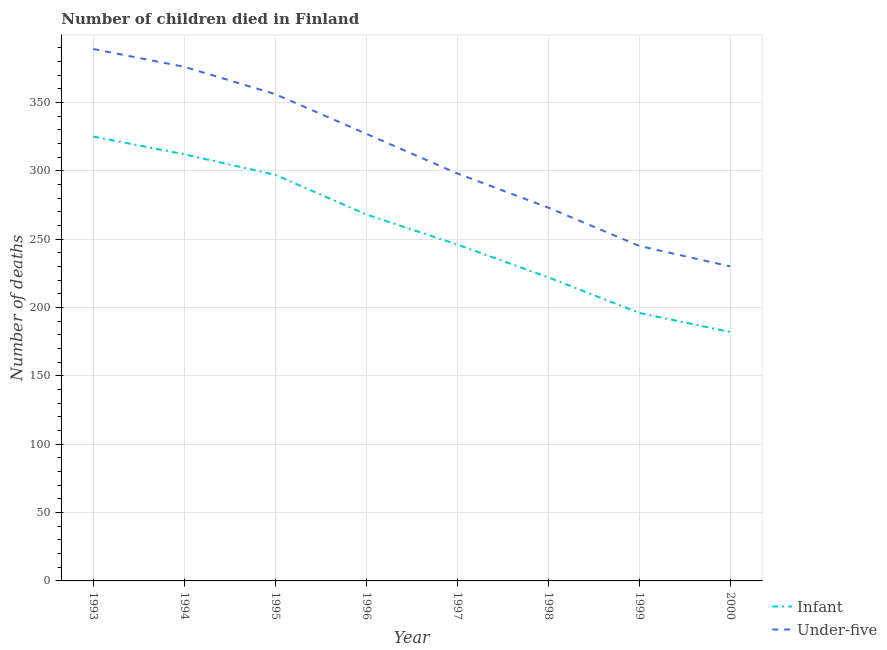What is the number of under-five deaths in 1998?
Offer a terse response. 273. Across all years, what is the maximum number of under-five deaths?
Offer a very short reply. 389. Across all years, what is the minimum number of under-five deaths?
Keep it short and to the point. 230. What is the total number of under-five deaths in the graph?
Keep it short and to the point. 2494. What is the difference between the number of under-five deaths in 1997 and that in 2000?
Keep it short and to the point. 68. What is the difference between the number of under-five deaths in 1998 and the number of infant deaths in 1996?
Your answer should be compact. 5. What is the average number of infant deaths per year?
Ensure brevity in your answer.  256. In the year 1993, what is the difference between the number of infant deaths and number of under-five deaths?
Provide a short and direct response. -64. What is the ratio of the number of infant deaths in 1993 to that in 2000?
Provide a short and direct response. 1.79. Is the number of under-five deaths in 1997 less than that in 1999?
Provide a short and direct response. No. What is the difference between the highest and the second highest number of under-five deaths?
Your answer should be compact. 13. What is the difference between the highest and the lowest number of under-five deaths?
Ensure brevity in your answer.  159. In how many years, is the number of under-five deaths greater than the average number of under-five deaths taken over all years?
Your response must be concise. 4. Is the number of infant deaths strictly less than the number of under-five deaths over the years?
Keep it short and to the point. Yes. How many years are there in the graph?
Your answer should be compact. 8. What is the difference between two consecutive major ticks on the Y-axis?
Keep it short and to the point. 50. Does the graph contain grids?
Provide a succinct answer. Yes. Where does the legend appear in the graph?
Your answer should be compact. Bottom right. What is the title of the graph?
Offer a terse response. Number of children died in Finland. What is the label or title of the Y-axis?
Provide a short and direct response. Number of deaths. What is the Number of deaths of Infant in 1993?
Keep it short and to the point. 325. What is the Number of deaths in Under-five in 1993?
Offer a terse response. 389. What is the Number of deaths in Infant in 1994?
Your answer should be very brief. 312. What is the Number of deaths of Under-five in 1994?
Keep it short and to the point. 376. What is the Number of deaths in Infant in 1995?
Your response must be concise. 297. What is the Number of deaths in Under-five in 1995?
Ensure brevity in your answer.  356. What is the Number of deaths of Infant in 1996?
Ensure brevity in your answer.  268. What is the Number of deaths of Under-five in 1996?
Your answer should be compact. 327. What is the Number of deaths in Infant in 1997?
Give a very brief answer. 246. What is the Number of deaths of Under-five in 1997?
Your answer should be compact. 298. What is the Number of deaths in Infant in 1998?
Provide a succinct answer. 222. What is the Number of deaths in Under-five in 1998?
Your answer should be very brief. 273. What is the Number of deaths of Infant in 1999?
Your answer should be compact. 196. What is the Number of deaths of Under-five in 1999?
Your answer should be very brief. 245. What is the Number of deaths in Infant in 2000?
Keep it short and to the point. 182. What is the Number of deaths of Under-five in 2000?
Your response must be concise. 230. Across all years, what is the maximum Number of deaths of Infant?
Provide a succinct answer. 325. Across all years, what is the maximum Number of deaths of Under-five?
Offer a terse response. 389. Across all years, what is the minimum Number of deaths of Infant?
Your response must be concise. 182. Across all years, what is the minimum Number of deaths in Under-five?
Give a very brief answer. 230. What is the total Number of deaths of Infant in the graph?
Ensure brevity in your answer.  2048. What is the total Number of deaths of Under-five in the graph?
Ensure brevity in your answer.  2494. What is the difference between the Number of deaths of Under-five in 1993 and that in 1994?
Your answer should be very brief. 13. What is the difference between the Number of deaths of Infant in 1993 and that in 1996?
Your response must be concise. 57. What is the difference between the Number of deaths of Under-five in 1993 and that in 1996?
Ensure brevity in your answer.  62. What is the difference between the Number of deaths of Infant in 1993 and that in 1997?
Offer a very short reply. 79. What is the difference between the Number of deaths in Under-five in 1993 and that in 1997?
Provide a succinct answer. 91. What is the difference between the Number of deaths of Infant in 1993 and that in 1998?
Provide a short and direct response. 103. What is the difference between the Number of deaths of Under-five in 1993 and that in 1998?
Make the answer very short. 116. What is the difference between the Number of deaths in Infant in 1993 and that in 1999?
Ensure brevity in your answer.  129. What is the difference between the Number of deaths in Under-five in 1993 and that in 1999?
Make the answer very short. 144. What is the difference between the Number of deaths of Infant in 1993 and that in 2000?
Provide a short and direct response. 143. What is the difference between the Number of deaths of Under-five in 1993 and that in 2000?
Your answer should be compact. 159. What is the difference between the Number of deaths of Infant in 1994 and that in 1995?
Keep it short and to the point. 15. What is the difference between the Number of deaths of Infant in 1994 and that in 1996?
Give a very brief answer. 44. What is the difference between the Number of deaths of Under-five in 1994 and that in 1996?
Offer a terse response. 49. What is the difference between the Number of deaths in Infant in 1994 and that in 1998?
Your response must be concise. 90. What is the difference between the Number of deaths in Under-five in 1994 and that in 1998?
Provide a short and direct response. 103. What is the difference between the Number of deaths in Infant in 1994 and that in 1999?
Keep it short and to the point. 116. What is the difference between the Number of deaths of Under-five in 1994 and that in 1999?
Make the answer very short. 131. What is the difference between the Number of deaths of Infant in 1994 and that in 2000?
Offer a terse response. 130. What is the difference between the Number of deaths of Under-five in 1994 and that in 2000?
Keep it short and to the point. 146. What is the difference between the Number of deaths in Infant in 1995 and that in 1997?
Keep it short and to the point. 51. What is the difference between the Number of deaths of Infant in 1995 and that in 1998?
Offer a terse response. 75. What is the difference between the Number of deaths of Infant in 1995 and that in 1999?
Ensure brevity in your answer.  101. What is the difference between the Number of deaths in Under-five in 1995 and that in 1999?
Provide a succinct answer. 111. What is the difference between the Number of deaths of Infant in 1995 and that in 2000?
Give a very brief answer. 115. What is the difference between the Number of deaths of Under-five in 1995 and that in 2000?
Ensure brevity in your answer.  126. What is the difference between the Number of deaths of Infant in 1996 and that in 1997?
Ensure brevity in your answer.  22. What is the difference between the Number of deaths of Under-five in 1996 and that in 1997?
Make the answer very short. 29. What is the difference between the Number of deaths of Infant in 1996 and that in 1998?
Give a very brief answer. 46. What is the difference between the Number of deaths in Infant in 1996 and that in 1999?
Offer a terse response. 72. What is the difference between the Number of deaths in Under-five in 1996 and that in 1999?
Ensure brevity in your answer.  82. What is the difference between the Number of deaths in Under-five in 1996 and that in 2000?
Your response must be concise. 97. What is the difference between the Number of deaths in Under-five in 1997 and that in 1999?
Offer a very short reply. 53. What is the difference between the Number of deaths of Under-five in 1997 and that in 2000?
Your response must be concise. 68. What is the difference between the Number of deaths in Infant in 1998 and that in 1999?
Give a very brief answer. 26. What is the difference between the Number of deaths in Under-five in 1998 and that in 1999?
Your response must be concise. 28. What is the difference between the Number of deaths in Under-five in 1998 and that in 2000?
Your response must be concise. 43. What is the difference between the Number of deaths of Infant in 1993 and the Number of deaths of Under-five in 1994?
Offer a terse response. -51. What is the difference between the Number of deaths of Infant in 1993 and the Number of deaths of Under-five in 1995?
Your answer should be compact. -31. What is the difference between the Number of deaths in Infant in 1993 and the Number of deaths in Under-five in 1996?
Provide a succinct answer. -2. What is the difference between the Number of deaths of Infant in 1993 and the Number of deaths of Under-five in 1997?
Your answer should be compact. 27. What is the difference between the Number of deaths in Infant in 1993 and the Number of deaths in Under-five in 2000?
Ensure brevity in your answer.  95. What is the difference between the Number of deaths of Infant in 1994 and the Number of deaths of Under-five in 1995?
Make the answer very short. -44. What is the difference between the Number of deaths in Infant in 1994 and the Number of deaths in Under-five in 1996?
Give a very brief answer. -15. What is the difference between the Number of deaths in Infant in 1994 and the Number of deaths in Under-five in 1998?
Offer a very short reply. 39. What is the difference between the Number of deaths in Infant in 1995 and the Number of deaths in Under-five in 1996?
Your response must be concise. -30. What is the difference between the Number of deaths in Infant in 1995 and the Number of deaths in Under-five in 2000?
Offer a terse response. 67. What is the difference between the Number of deaths in Infant in 1996 and the Number of deaths in Under-five in 1997?
Provide a succinct answer. -30. What is the difference between the Number of deaths in Infant in 1998 and the Number of deaths in Under-five in 1999?
Ensure brevity in your answer.  -23. What is the difference between the Number of deaths in Infant in 1999 and the Number of deaths in Under-five in 2000?
Your response must be concise. -34. What is the average Number of deaths in Infant per year?
Your answer should be compact. 256. What is the average Number of deaths of Under-five per year?
Your answer should be compact. 311.75. In the year 1993, what is the difference between the Number of deaths of Infant and Number of deaths of Under-five?
Give a very brief answer. -64. In the year 1994, what is the difference between the Number of deaths in Infant and Number of deaths in Under-five?
Offer a terse response. -64. In the year 1995, what is the difference between the Number of deaths in Infant and Number of deaths in Under-five?
Provide a succinct answer. -59. In the year 1996, what is the difference between the Number of deaths in Infant and Number of deaths in Under-five?
Make the answer very short. -59. In the year 1997, what is the difference between the Number of deaths in Infant and Number of deaths in Under-five?
Make the answer very short. -52. In the year 1998, what is the difference between the Number of deaths in Infant and Number of deaths in Under-five?
Make the answer very short. -51. In the year 1999, what is the difference between the Number of deaths in Infant and Number of deaths in Under-five?
Your answer should be very brief. -49. In the year 2000, what is the difference between the Number of deaths of Infant and Number of deaths of Under-five?
Your answer should be very brief. -48. What is the ratio of the Number of deaths of Infant in 1993 to that in 1994?
Keep it short and to the point. 1.04. What is the ratio of the Number of deaths in Under-five in 1993 to that in 1994?
Your response must be concise. 1.03. What is the ratio of the Number of deaths of Infant in 1993 to that in 1995?
Keep it short and to the point. 1.09. What is the ratio of the Number of deaths in Under-five in 1993 to that in 1995?
Keep it short and to the point. 1.09. What is the ratio of the Number of deaths in Infant in 1993 to that in 1996?
Offer a very short reply. 1.21. What is the ratio of the Number of deaths of Under-five in 1993 to that in 1996?
Make the answer very short. 1.19. What is the ratio of the Number of deaths of Infant in 1993 to that in 1997?
Ensure brevity in your answer.  1.32. What is the ratio of the Number of deaths of Under-five in 1993 to that in 1997?
Ensure brevity in your answer.  1.31. What is the ratio of the Number of deaths of Infant in 1993 to that in 1998?
Make the answer very short. 1.46. What is the ratio of the Number of deaths in Under-five in 1993 to that in 1998?
Provide a short and direct response. 1.42. What is the ratio of the Number of deaths of Infant in 1993 to that in 1999?
Make the answer very short. 1.66. What is the ratio of the Number of deaths of Under-five in 1993 to that in 1999?
Offer a very short reply. 1.59. What is the ratio of the Number of deaths in Infant in 1993 to that in 2000?
Keep it short and to the point. 1.79. What is the ratio of the Number of deaths of Under-five in 1993 to that in 2000?
Provide a short and direct response. 1.69. What is the ratio of the Number of deaths of Infant in 1994 to that in 1995?
Keep it short and to the point. 1.05. What is the ratio of the Number of deaths of Under-five in 1994 to that in 1995?
Offer a very short reply. 1.06. What is the ratio of the Number of deaths of Infant in 1994 to that in 1996?
Keep it short and to the point. 1.16. What is the ratio of the Number of deaths of Under-five in 1994 to that in 1996?
Offer a very short reply. 1.15. What is the ratio of the Number of deaths of Infant in 1994 to that in 1997?
Offer a terse response. 1.27. What is the ratio of the Number of deaths in Under-five in 1994 to that in 1997?
Offer a terse response. 1.26. What is the ratio of the Number of deaths of Infant in 1994 to that in 1998?
Your response must be concise. 1.41. What is the ratio of the Number of deaths in Under-five in 1994 to that in 1998?
Your answer should be very brief. 1.38. What is the ratio of the Number of deaths of Infant in 1994 to that in 1999?
Your response must be concise. 1.59. What is the ratio of the Number of deaths in Under-five in 1994 to that in 1999?
Your response must be concise. 1.53. What is the ratio of the Number of deaths of Infant in 1994 to that in 2000?
Keep it short and to the point. 1.71. What is the ratio of the Number of deaths in Under-five in 1994 to that in 2000?
Your response must be concise. 1.63. What is the ratio of the Number of deaths of Infant in 1995 to that in 1996?
Give a very brief answer. 1.11. What is the ratio of the Number of deaths in Under-five in 1995 to that in 1996?
Your answer should be compact. 1.09. What is the ratio of the Number of deaths in Infant in 1995 to that in 1997?
Offer a very short reply. 1.21. What is the ratio of the Number of deaths of Under-five in 1995 to that in 1997?
Provide a succinct answer. 1.19. What is the ratio of the Number of deaths in Infant in 1995 to that in 1998?
Your answer should be compact. 1.34. What is the ratio of the Number of deaths of Under-five in 1995 to that in 1998?
Your answer should be compact. 1.3. What is the ratio of the Number of deaths of Infant in 1995 to that in 1999?
Your response must be concise. 1.52. What is the ratio of the Number of deaths in Under-five in 1995 to that in 1999?
Provide a succinct answer. 1.45. What is the ratio of the Number of deaths in Infant in 1995 to that in 2000?
Your answer should be compact. 1.63. What is the ratio of the Number of deaths in Under-five in 1995 to that in 2000?
Make the answer very short. 1.55. What is the ratio of the Number of deaths of Infant in 1996 to that in 1997?
Offer a very short reply. 1.09. What is the ratio of the Number of deaths in Under-five in 1996 to that in 1997?
Make the answer very short. 1.1. What is the ratio of the Number of deaths of Infant in 1996 to that in 1998?
Provide a succinct answer. 1.21. What is the ratio of the Number of deaths of Under-five in 1996 to that in 1998?
Make the answer very short. 1.2. What is the ratio of the Number of deaths in Infant in 1996 to that in 1999?
Make the answer very short. 1.37. What is the ratio of the Number of deaths in Under-five in 1996 to that in 1999?
Your answer should be compact. 1.33. What is the ratio of the Number of deaths in Infant in 1996 to that in 2000?
Your answer should be compact. 1.47. What is the ratio of the Number of deaths of Under-five in 1996 to that in 2000?
Give a very brief answer. 1.42. What is the ratio of the Number of deaths in Infant in 1997 to that in 1998?
Ensure brevity in your answer.  1.11. What is the ratio of the Number of deaths of Under-five in 1997 to that in 1998?
Offer a very short reply. 1.09. What is the ratio of the Number of deaths of Infant in 1997 to that in 1999?
Keep it short and to the point. 1.26. What is the ratio of the Number of deaths in Under-five in 1997 to that in 1999?
Your answer should be compact. 1.22. What is the ratio of the Number of deaths in Infant in 1997 to that in 2000?
Your response must be concise. 1.35. What is the ratio of the Number of deaths of Under-five in 1997 to that in 2000?
Your answer should be very brief. 1.3. What is the ratio of the Number of deaths in Infant in 1998 to that in 1999?
Offer a very short reply. 1.13. What is the ratio of the Number of deaths of Under-five in 1998 to that in 1999?
Your response must be concise. 1.11. What is the ratio of the Number of deaths in Infant in 1998 to that in 2000?
Your response must be concise. 1.22. What is the ratio of the Number of deaths in Under-five in 1998 to that in 2000?
Give a very brief answer. 1.19. What is the ratio of the Number of deaths in Infant in 1999 to that in 2000?
Offer a terse response. 1.08. What is the ratio of the Number of deaths of Under-five in 1999 to that in 2000?
Offer a terse response. 1.07. What is the difference between the highest and the second highest Number of deaths in Under-five?
Provide a succinct answer. 13. What is the difference between the highest and the lowest Number of deaths in Infant?
Provide a short and direct response. 143. What is the difference between the highest and the lowest Number of deaths in Under-five?
Your answer should be very brief. 159. 